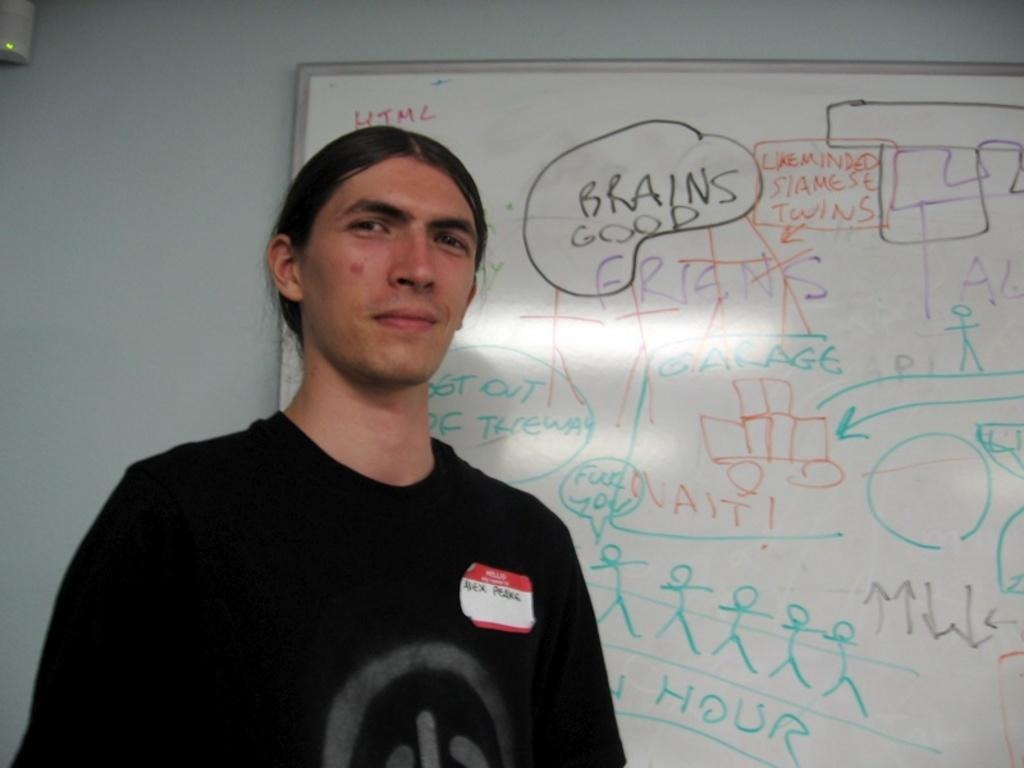Provide a one-sentence caption for the provided image. A man with a name tag identifying him as Alex stands in front of a white board. 